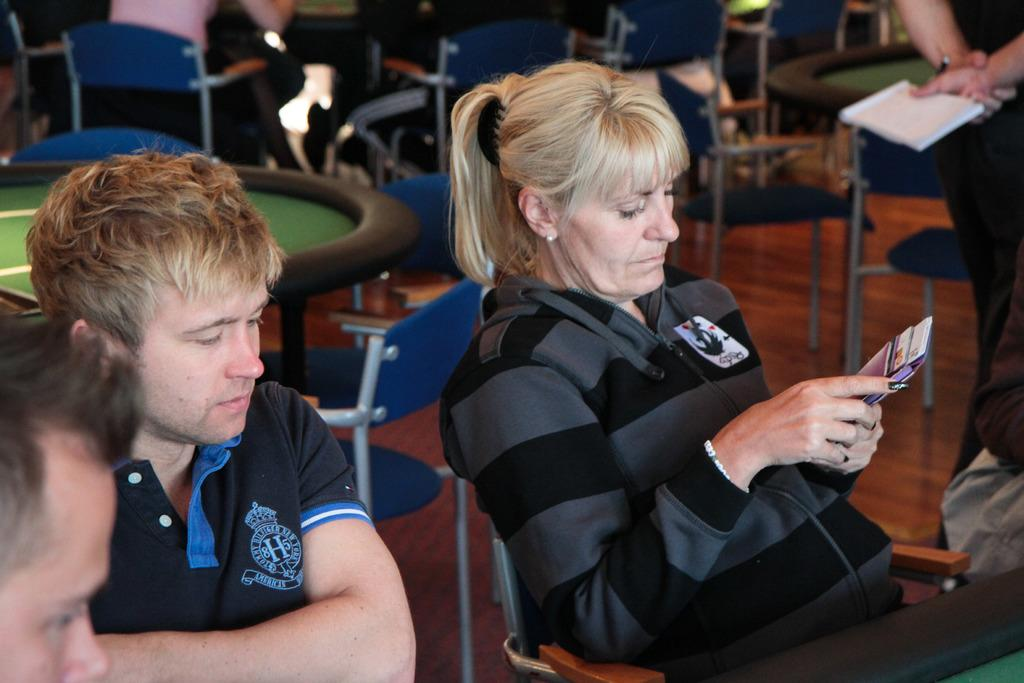How many chairs are visible in the image? There are many chairs in the image. What are some people doing with the chairs? Some people are sitting on the chairs. Can you describe what the lady is holding in her hand? A lady is holding something in her hand, but the image does not provide enough detail to determine what it is. What is the purpose of the table in the image? The table in the image might be used for placing objects or for people to put their belongings. What is the person on the right side holding in their hand? The person on the right side is holding a book in their hand. What type of feather can be seen on the cemetery in the image? There is no cemetery or feather present in the image. What achievement has the lady accomplished, as seen in the image? The image does not provide any information about the lady's achievements. 